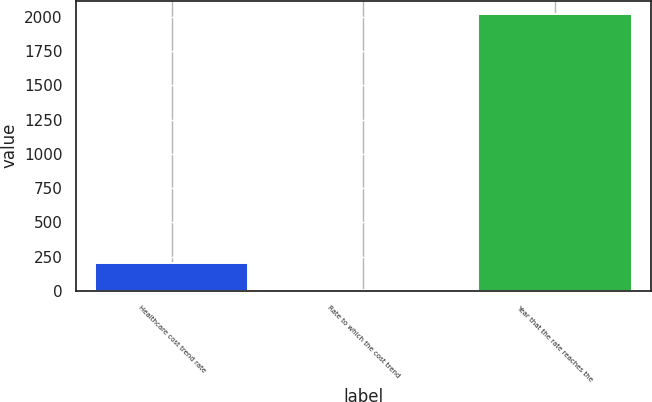Convert chart to OTSL. <chart><loc_0><loc_0><loc_500><loc_500><bar_chart><fcel>Healthcare cost trend rate<fcel>Rate to which the cost trend<fcel>Year that the rate reaches the<nl><fcel>205.86<fcel>4.51<fcel>2018<nl></chart> 